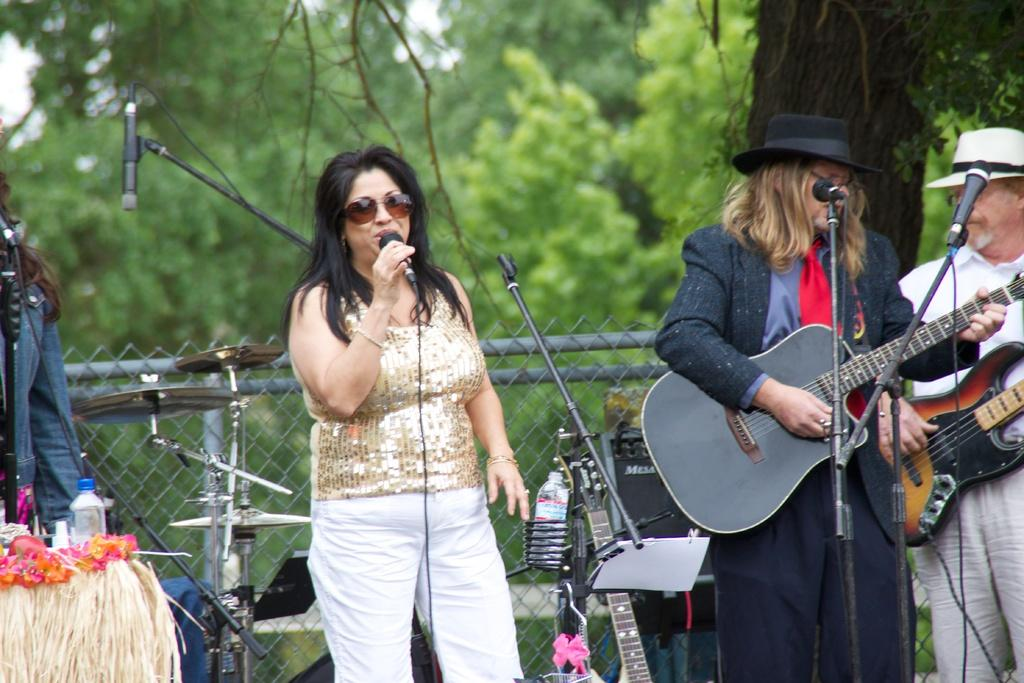Who is the main subject in the image? There is a woman in the image. What is the woman doing in the image? The woman is standing and holding a mic in her hand. Are there any other people in the image? Yes, there are people in the image. What are the people doing in the image? The people are holding guitars in their hands. What is the woman thinking about in the image? The image does not provide information about the woman's thoughts, so we cannot determine what she is thinking about. 